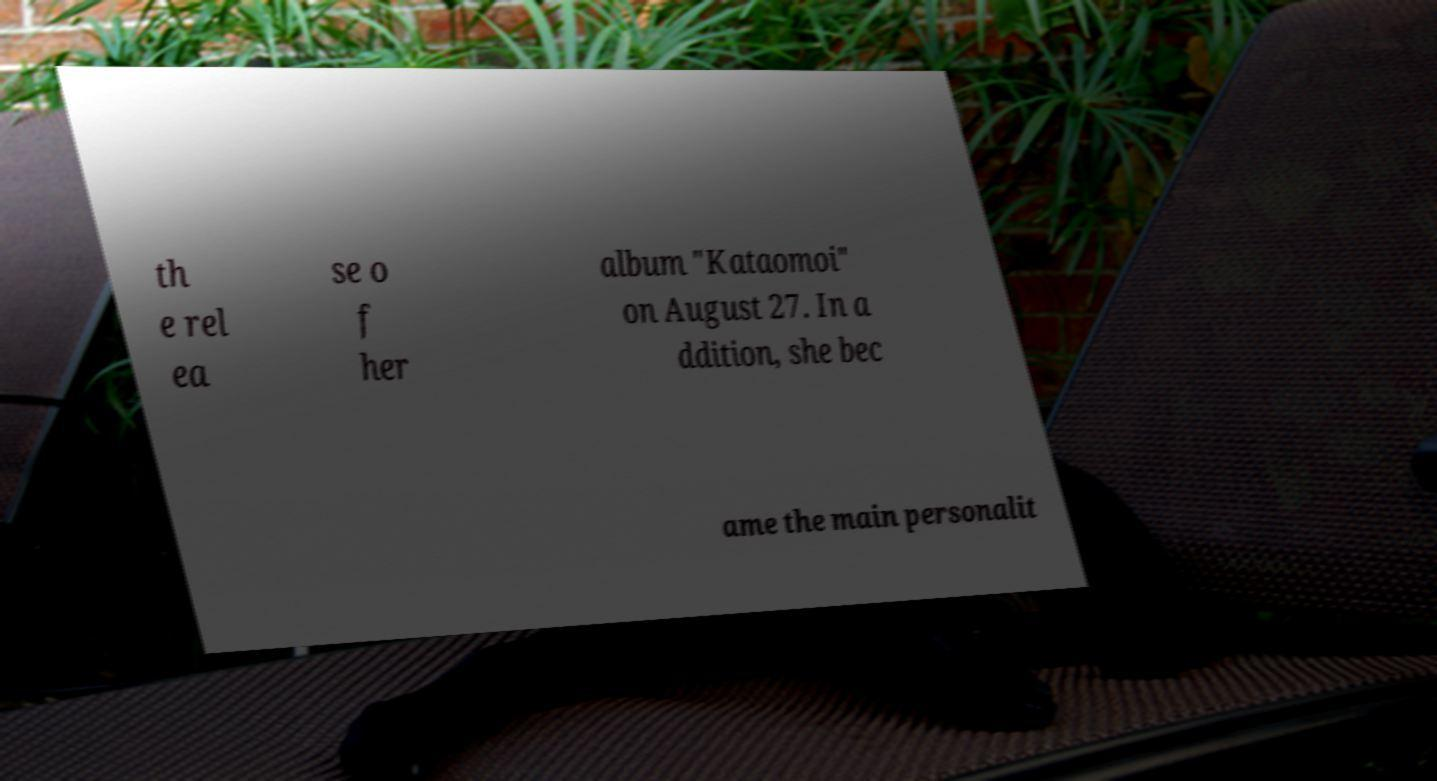Could you extract and type out the text from this image? th e rel ea se o f her album "Kataomoi" on August 27. In a ddition, she bec ame the main personalit 